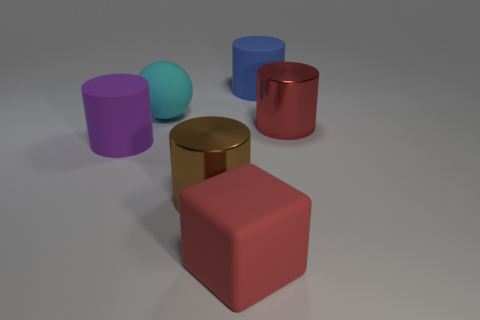Subtract all red cylinders. How many cylinders are left? 3 Add 1 purple matte cylinders. How many objects exist? 7 Subtract 2 cylinders. How many cylinders are left? 2 Subtract all blue cylinders. How many cylinders are left? 3 Subtract all cyan cubes. Subtract all red cylinders. How many cubes are left? 1 Subtract all blue cylinders. How many blue balls are left? 0 Subtract all red shiny blocks. Subtract all big purple cylinders. How many objects are left? 5 Add 5 big brown shiny cylinders. How many big brown shiny cylinders are left? 6 Add 3 small red rubber cylinders. How many small red rubber cylinders exist? 3 Subtract 1 red cubes. How many objects are left? 5 